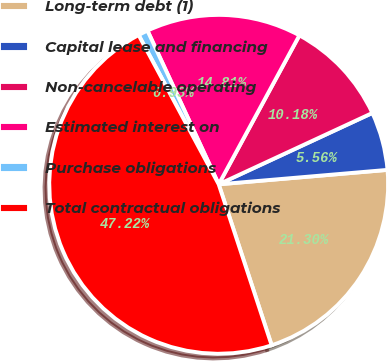Convert chart to OTSL. <chart><loc_0><loc_0><loc_500><loc_500><pie_chart><fcel>Long-term debt (1)<fcel>Capital lease and financing<fcel>Non-cancelable operating<fcel>Estimated interest on<fcel>Purchase obligations<fcel>Total contractual obligations<nl><fcel>21.3%<fcel>5.56%<fcel>10.18%<fcel>14.81%<fcel>0.93%<fcel>47.22%<nl></chart> 